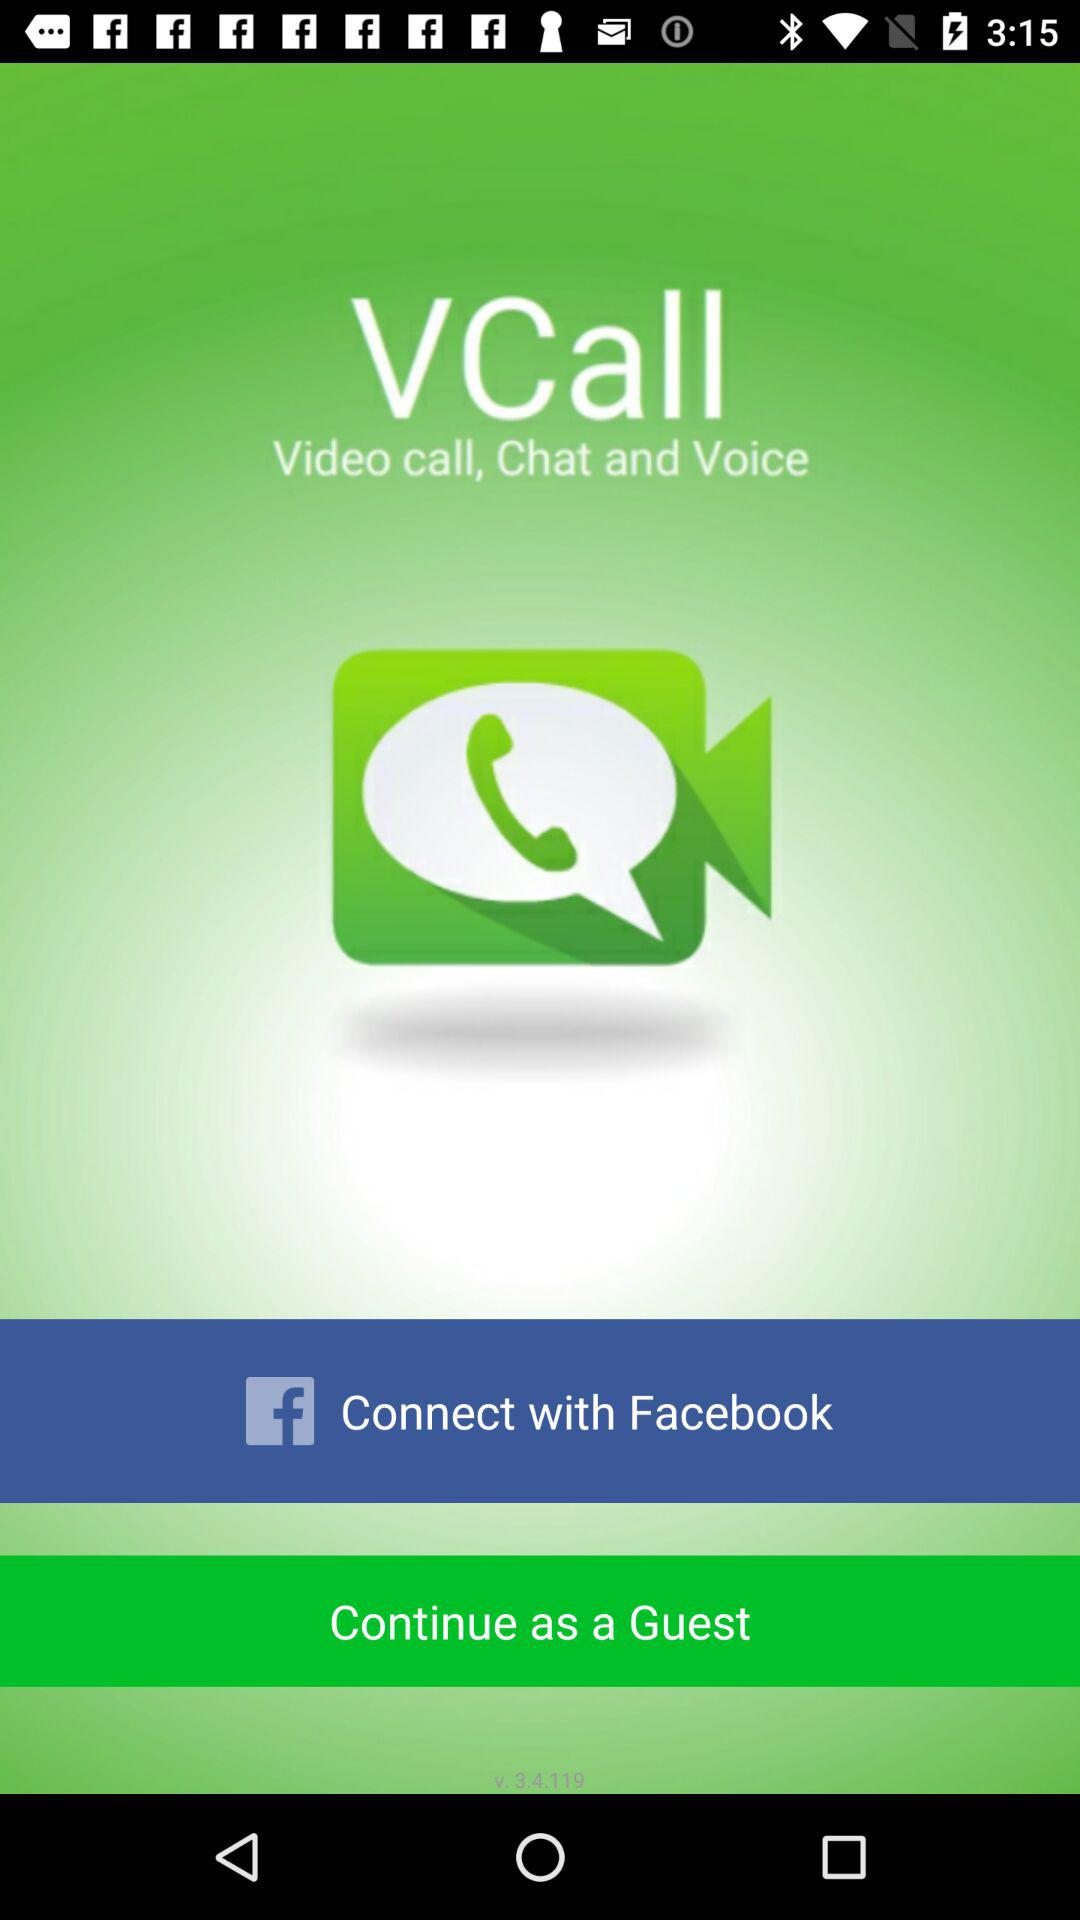What is the name of the application? The name of the application is "VCall". 